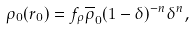<formula> <loc_0><loc_0><loc_500><loc_500>\rho _ { 0 } ( r _ { 0 } ) = f _ { \rho } \overline { \rho } _ { 0 } ( 1 - \delta ) ^ { - n } \delta ^ { n } ,</formula> 